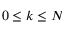Convert formula to latex. <formula><loc_0><loc_0><loc_500><loc_500>0 \leq k \leq N</formula> 